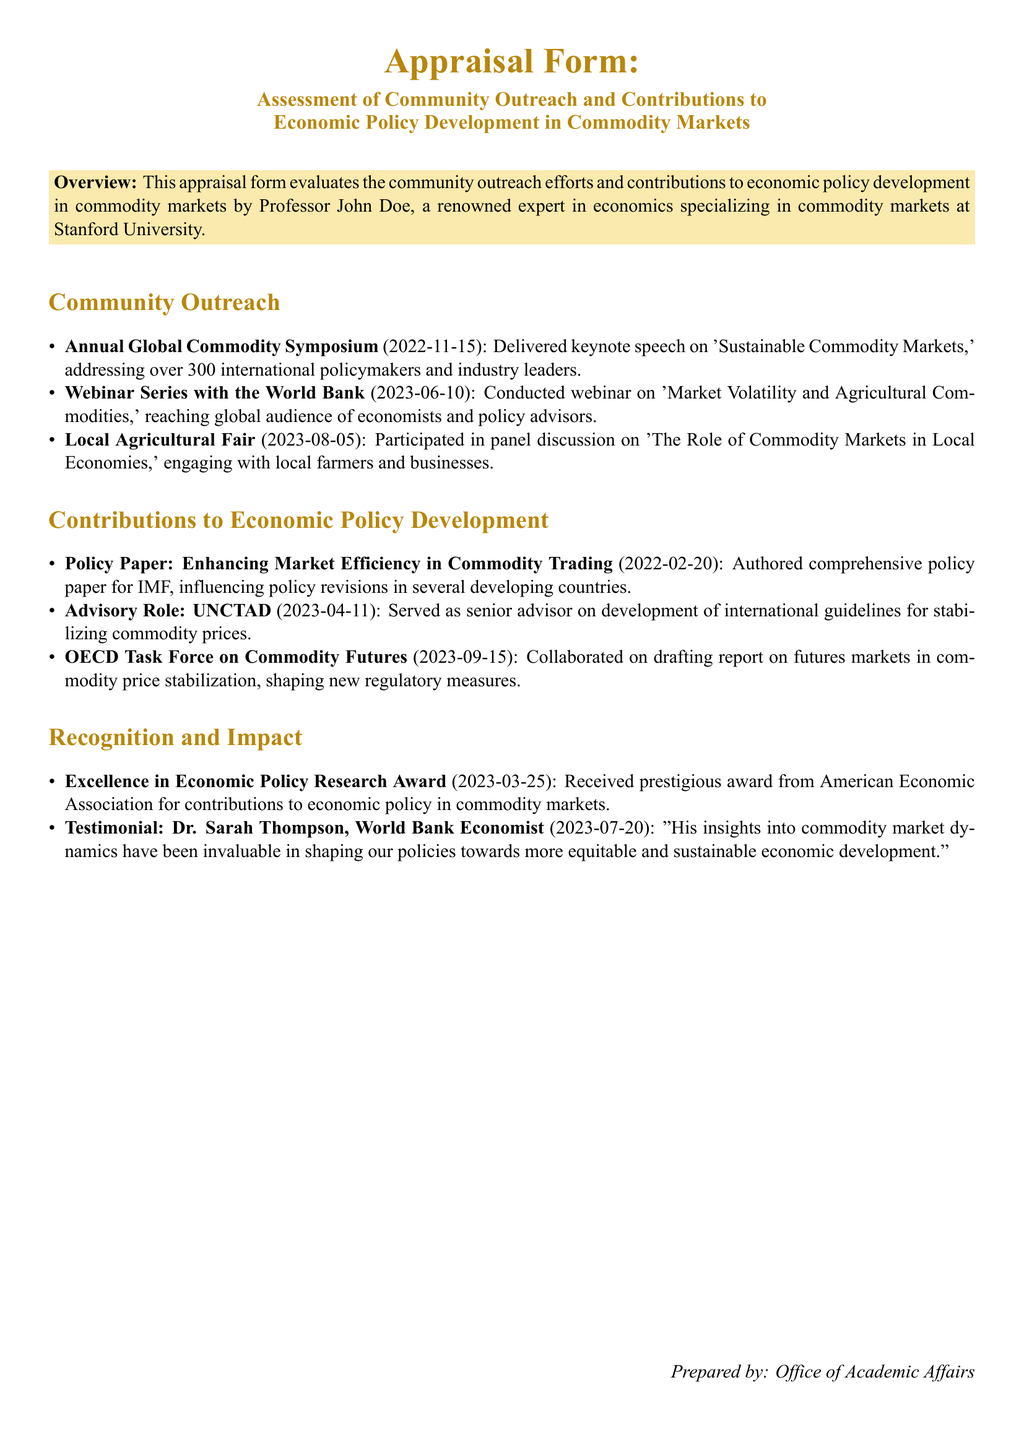What was the keynote speech topic at the Annual Global Commodity Symposium? The document states that the keynote speech was on 'Sustainable Commodity Markets.'
Answer: Sustainable Commodity Markets Who participated in the panel discussion at the Local Agricultural Fair? The document specifies that Professor John Doe engaged with local farmers and businesses during the panel discussion.
Answer: Professor John Doe When was the policy paper authored for IMF? The date in the document indicates that the policy paper was authored on 2022-02-20.
Answer: 2022-02-20 What organization did Professor John Doe serve as a senior advisor for? The document highlights that he served as a senior advisor for UNCTAD.
Answer: UNCTAD How many international policymakers and industry leaders attended the Annual Global Commodity Symposium? The document notes that over 300 international policymakers and industry leaders attended.
Answer: over 300 What award did Professor John Doe receive on 2023-03-25? According to the document, he received the Excellence in Economic Policy Research Award.
Answer: Excellence in Economic Policy Research Award What was the focus of the webinar conducted on 2023-06-10? The document states the webinar was on 'Market Volatility and Agricultural Commodities.'
Answer: Market Volatility and Agricultural Commodities Which task force did Professor John Doe collaborate with on a report? The document specifies that he collaborated with the OECD Task Force on Commodity Futures.
Answer: OECD Task Force on Commodity Futures What did Dr. Sarah Thompson describe Professor John Doe's insights as? The document includes a testimonial stating that his insights were invaluable.
Answer: invaluable 